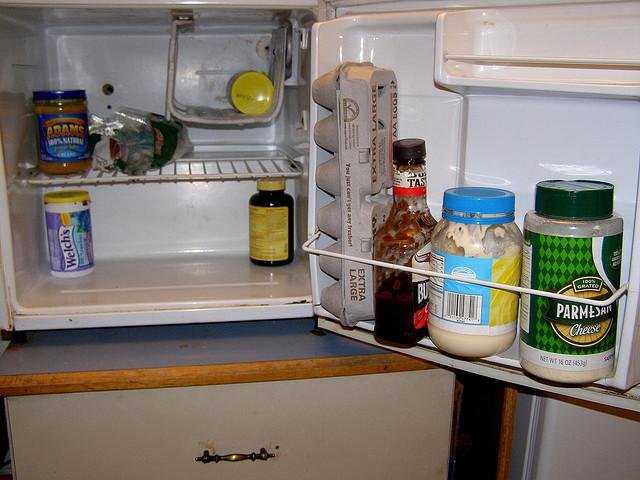How many objects here contain items from the dairy group? Please explain your reasoning. three. There are 3. 